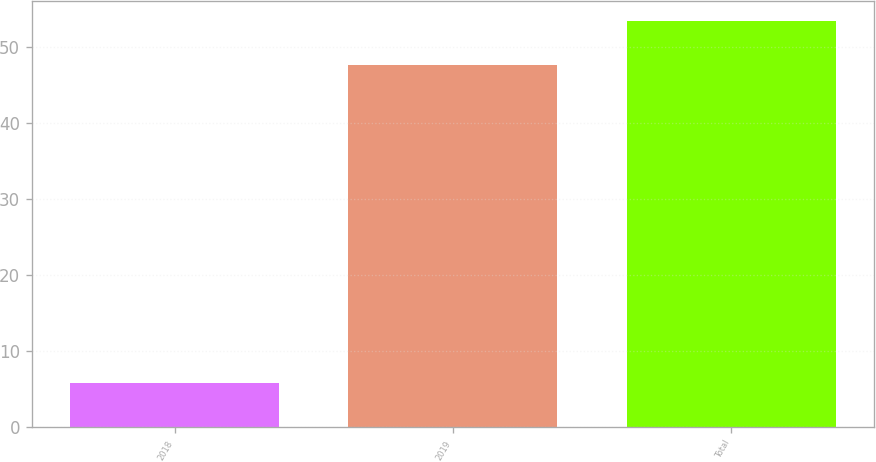<chart> <loc_0><loc_0><loc_500><loc_500><bar_chart><fcel>2018<fcel>2019<fcel>Total<nl><fcel>5.8<fcel>47.6<fcel>53.4<nl></chart> 